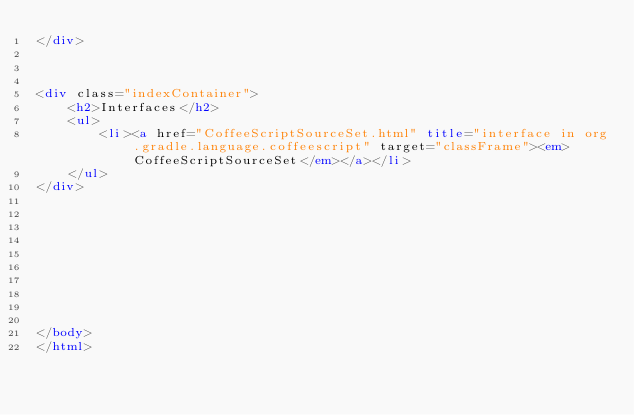Convert code to text. <code><loc_0><loc_0><loc_500><loc_500><_HTML_></div>



<div class="indexContainer">
    <h2>Interfaces</h2>
    <ul>
        <li><a href="CoffeeScriptSourceSet.html" title="interface in org.gradle.language.coffeescript" target="classFrame"><em>CoffeeScriptSourceSet</em></a></li>
    </ul>
</div>










</body>
</html>
</code> 